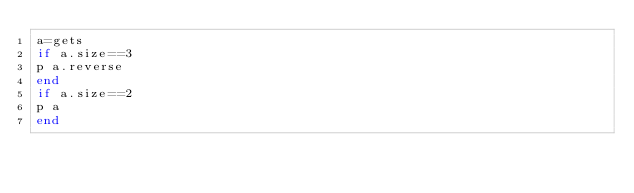Convert code to text. <code><loc_0><loc_0><loc_500><loc_500><_Ruby_>a=gets
if a.size==3
p a.reverse
end
if a.size==2
p a
end
</code> 